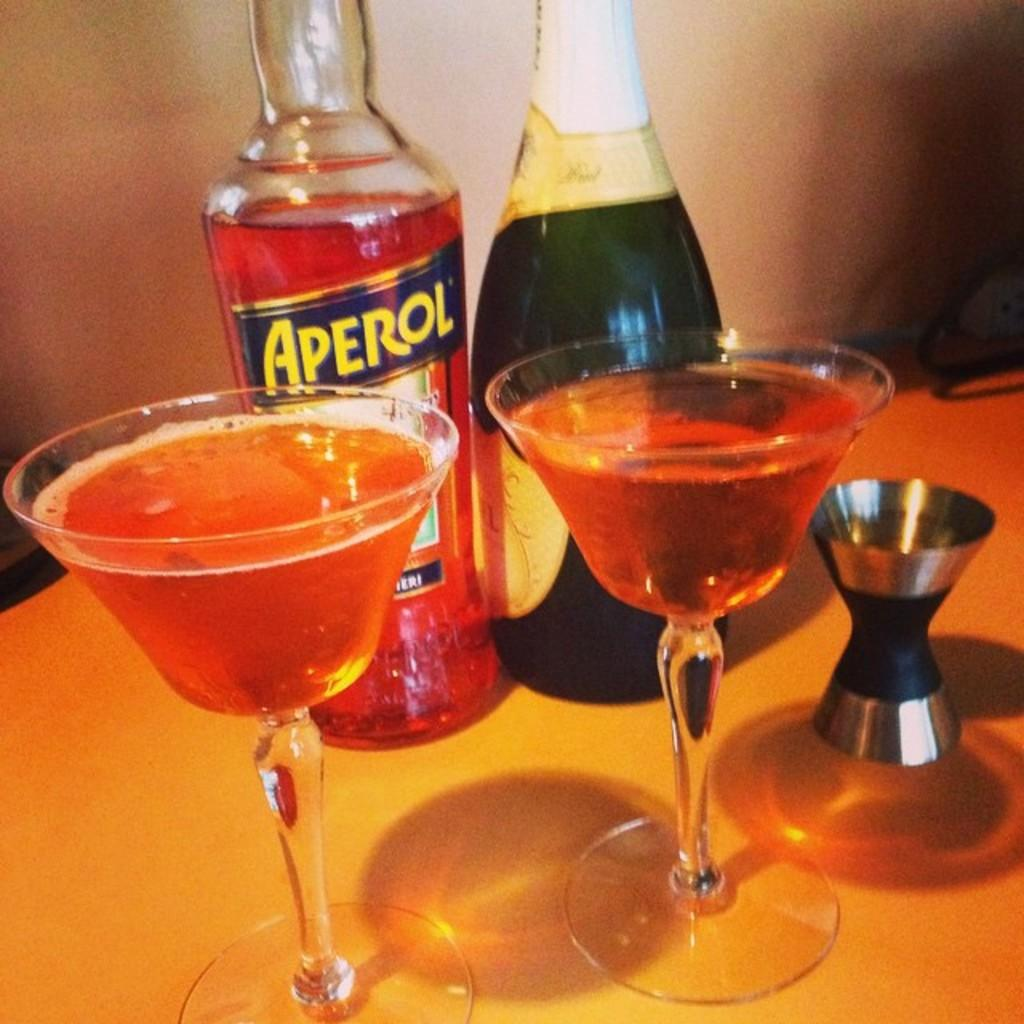How many bottles can be seen in the image? There are two bottles in the image. What else is present on the table besides the bottles? There are glasses with a drink in the image. What is visible in the background of the image? There is a wall in the background of the image. What is the name of the spy who is hiding behind the wall in the image? There is no spy present in the image, and therefore no name can be provided. Can you identify the type of fowl that is perched on the table in the image? There is no fowl present on the table in the image. 